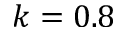<formula> <loc_0><loc_0><loc_500><loc_500>k = 0 . 8</formula> 